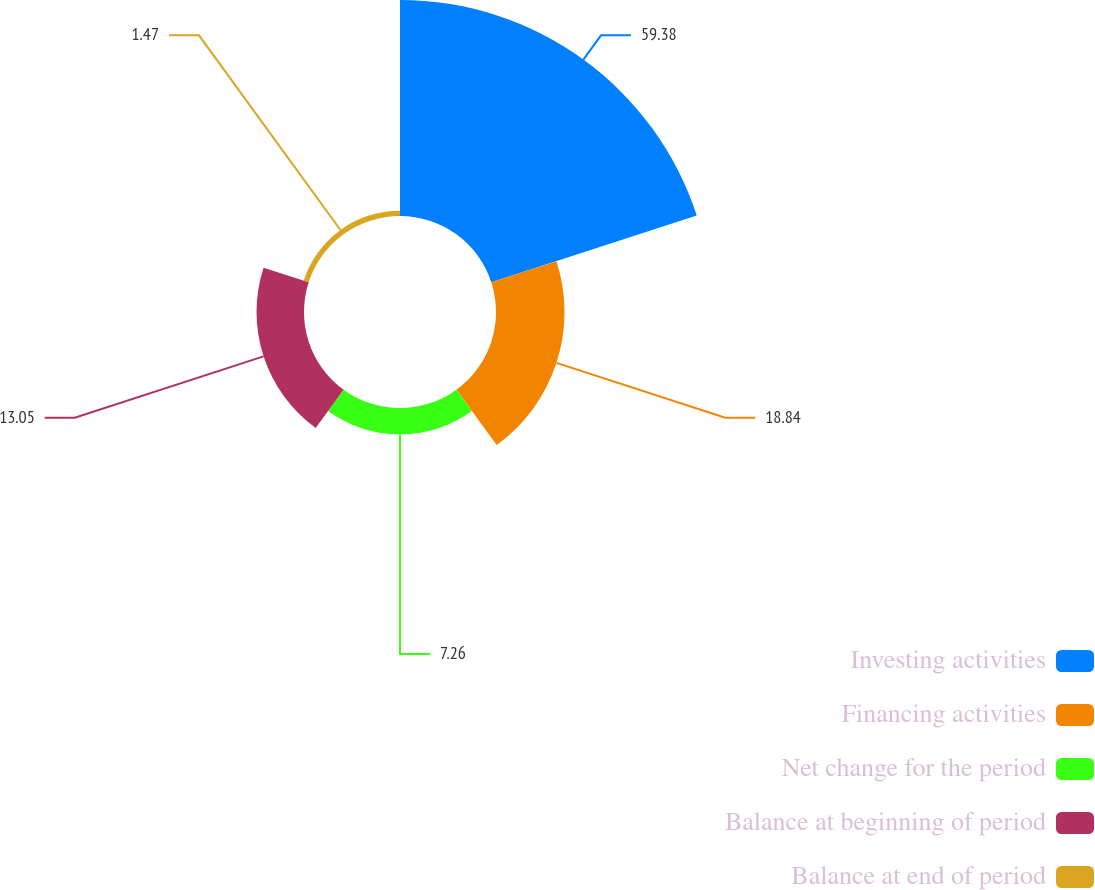<chart> <loc_0><loc_0><loc_500><loc_500><pie_chart><fcel>Investing activities<fcel>Financing activities<fcel>Net change for the period<fcel>Balance at beginning of period<fcel>Balance at end of period<nl><fcel>59.39%<fcel>18.84%<fcel>7.26%<fcel>13.05%<fcel>1.47%<nl></chart> 